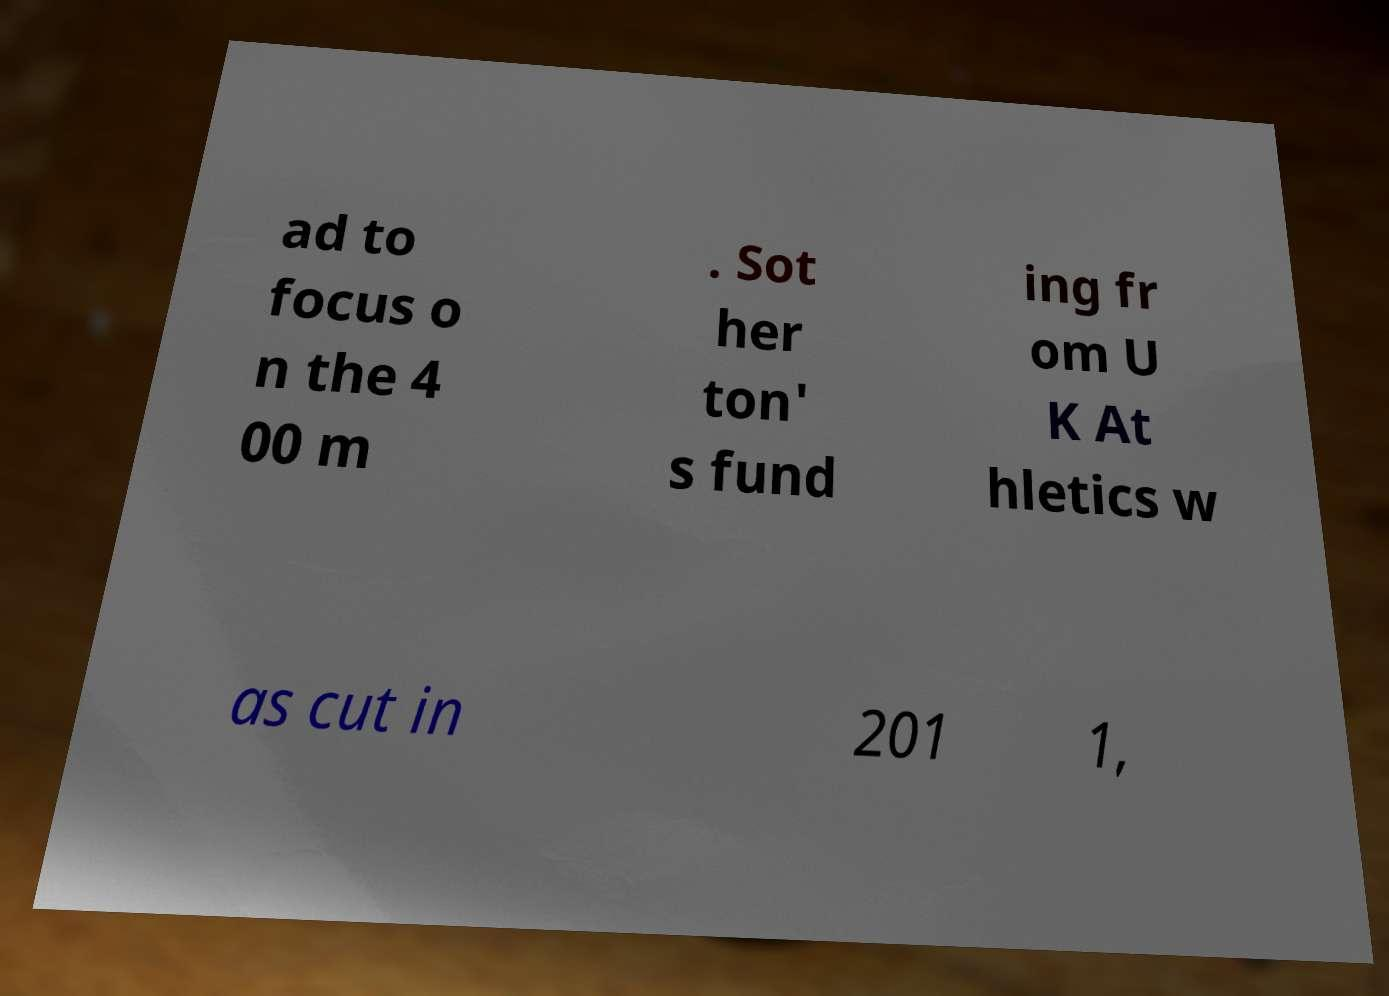Could you assist in decoding the text presented in this image and type it out clearly? ad to focus o n the 4 00 m . Sot her ton' s fund ing fr om U K At hletics w as cut in 201 1, 